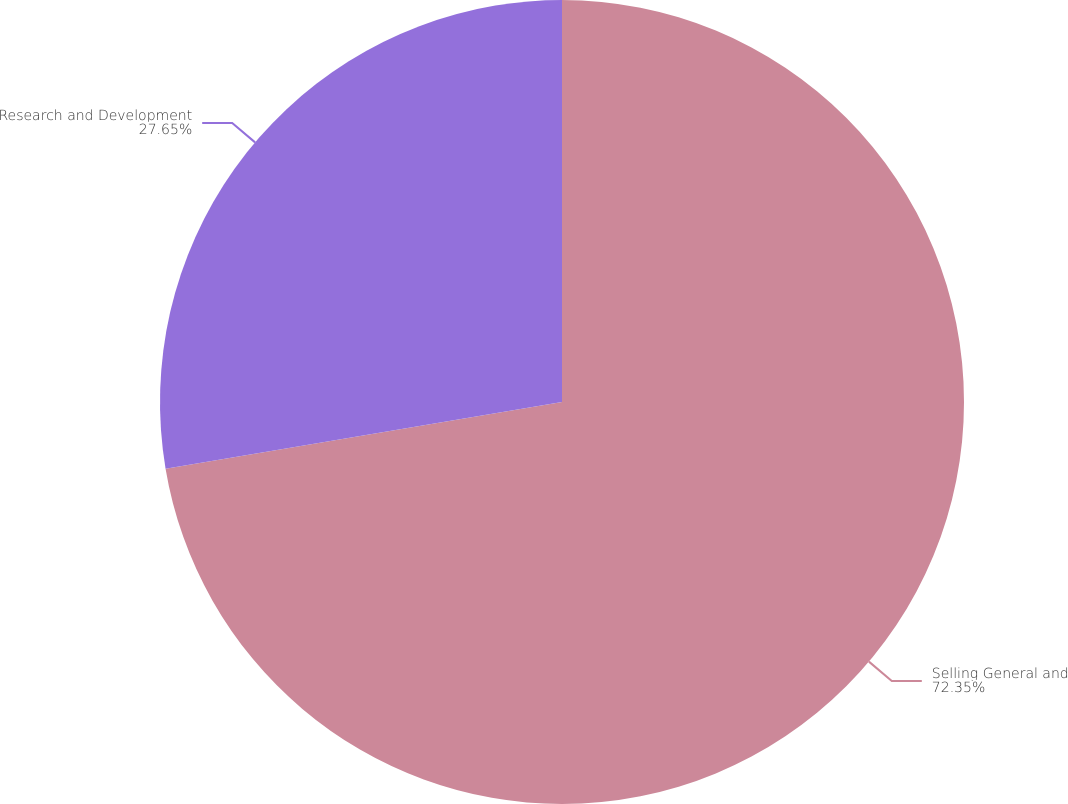<chart> <loc_0><loc_0><loc_500><loc_500><pie_chart><fcel>Selling General and<fcel>Research and Development<nl><fcel>72.35%<fcel>27.65%<nl></chart> 